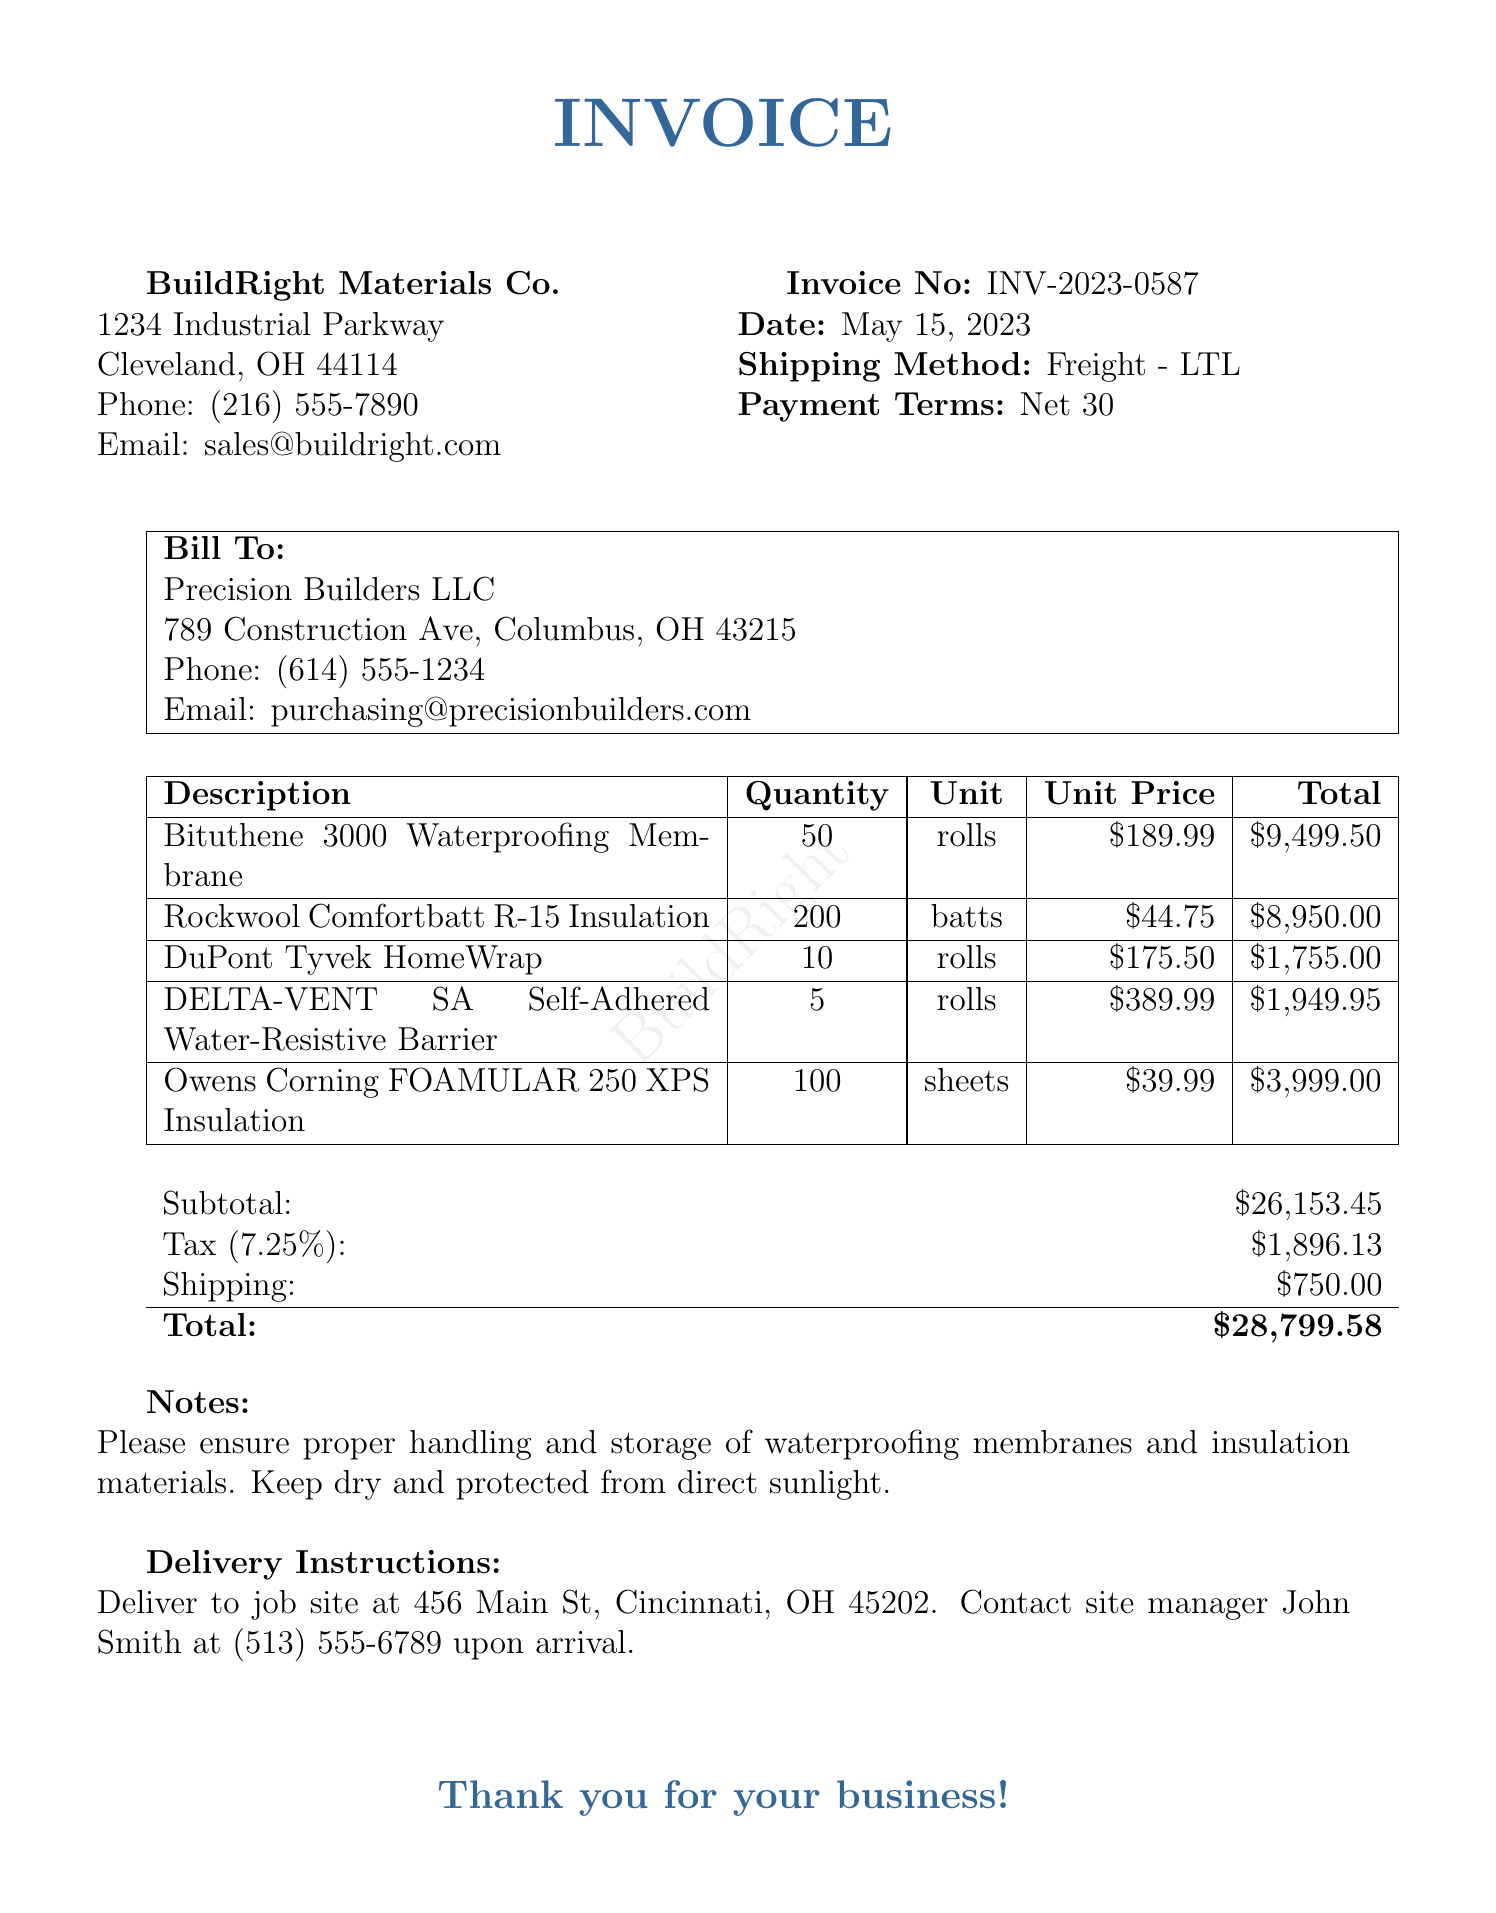what is the invoice number? The invoice number is referenced at the top of the document under "Invoice No," which is INV-2023-0587.
Answer: INV-2023-0587 who is the supplier? The supplier's name is provided in the document under the supplier details section, which lists BuildRight Materials Co.
Answer: BuildRight Materials Co what is the subtotal amount? The subtotal is listed in the total calculations; it is before tax and shipping, which is $26153.45.
Answer: $26153.45 how many rolls of Bituthene 3000 Waterproofing Membrane were ordered? The quantity of Bituthene 3000 Waterproofing Membrane is listed in the items section as 50 rolls.
Answer: 50 rolls what are the payment terms? The payment terms are found in the header section and state that payment is due "Net 30."
Answer: Net 30 what is the tax rate applied? The tax rate is noted in the tax section of the document as 7.25%.
Answer: 7.25% who should be contacted upon delivery? The contact for delivery is mentioned in the delivery instructions, naming John Smith as the site manager.
Answer: John Smith what is the total amount due? The total amount is calculated and presented at the end of the invoice as the final amount due, which is $28799.58.
Answer: $28799.58 what is the shipping method used? The shipping method is specified in the header section as "Freight - LTL."
Answer: Freight - LTL 